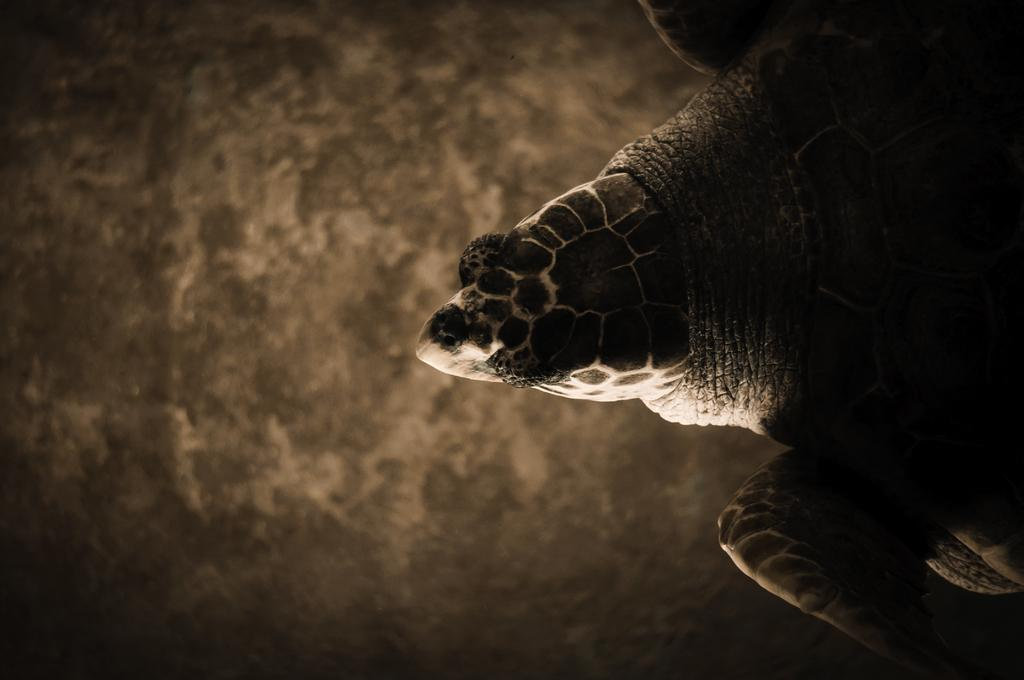What animal can be seen on the right side of the image? There is a turtle on the right side of the image. Can you describe the background of the image? The background of the image is blurred. What type of insurance policy is the turtle holding in the image? There is no insurance policy or any indication of insurance in the image; it features a turtle and a blurred background. 